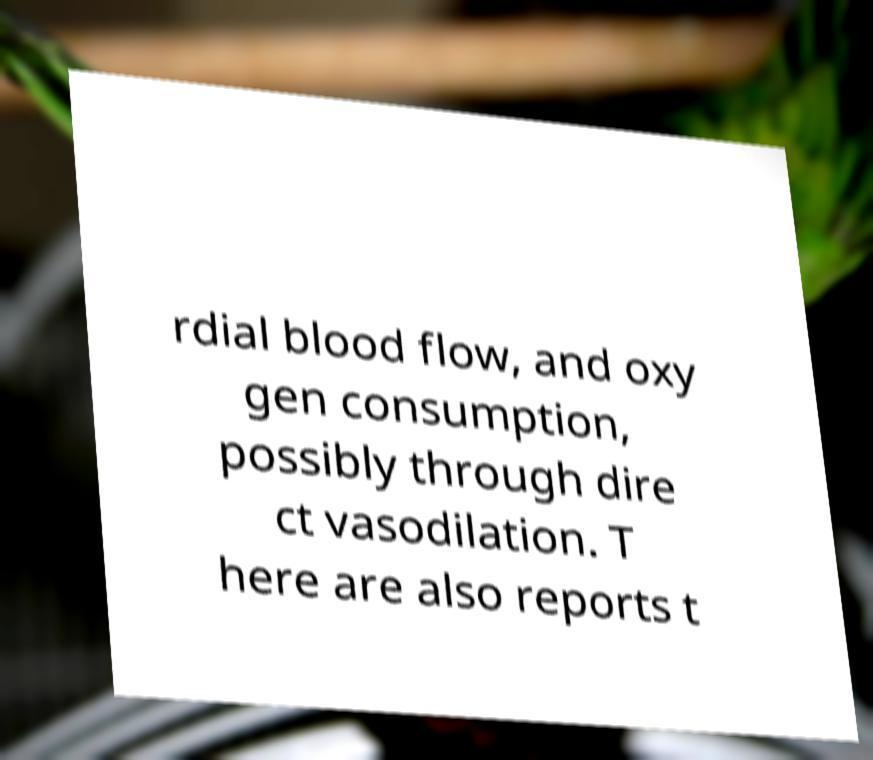There's text embedded in this image that I need extracted. Can you transcribe it verbatim? rdial blood flow, and oxy gen consumption, possibly through dire ct vasodilation. T here are also reports t 